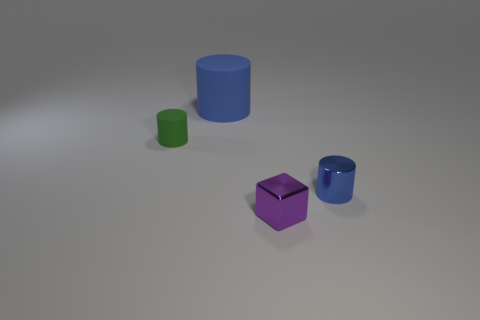Do the blue rubber thing and the purple shiny thing have the same size?
Ensure brevity in your answer.  No. How many metal things are left of the large cylinder?
Your answer should be very brief. 0. Are there an equal number of small purple metallic blocks that are behind the big blue rubber cylinder and green rubber things to the right of the block?
Keep it short and to the point. Yes. There is a object behind the tiny rubber object; is its shape the same as the purple shiny thing?
Ensure brevity in your answer.  No. Is there any other thing that is the same material as the large cylinder?
Ensure brevity in your answer.  Yes. There is a purple object; does it have the same size as the blue thing that is to the left of the small blue cylinder?
Your response must be concise. No. What number of other things are there of the same color as the small rubber thing?
Give a very brief answer. 0. Are there any objects right of the tiny rubber thing?
Your answer should be compact. Yes. What number of objects are small green rubber cylinders or cylinders that are behind the metal block?
Offer a very short reply. 3. Is there a big cylinder that is on the right side of the tiny metallic thing that is on the right side of the purple thing?
Provide a succinct answer. No. 